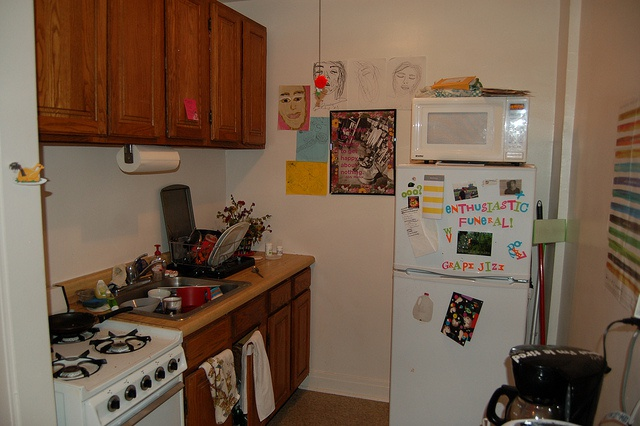Describe the objects in this image and their specific colors. I can see refrigerator in gray and darkgray tones, oven in gray, darkgray, and black tones, microwave in gray, darkgray, and lightgray tones, sink in gray, black, and maroon tones, and potted plant in gray, black, and maroon tones in this image. 